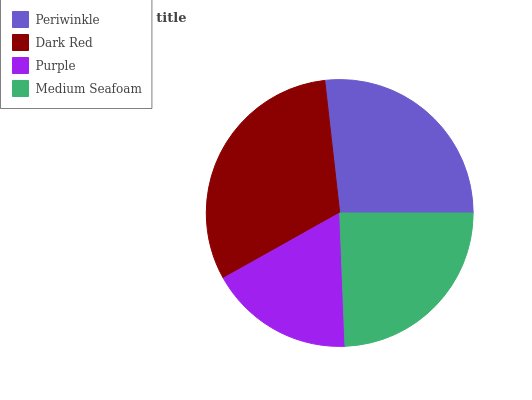Is Purple the minimum?
Answer yes or no. Yes. Is Dark Red the maximum?
Answer yes or no. Yes. Is Dark Red the minimum?
Answer yes or no. No. Is Purple the maximum?
Answer yes or no. No. Is Dark Red greater than Purple?
Answer yes or no. Yes. Is Purple less than Dark Red?
Answer yes or no. Yes. Is Purple greater than Dark Red?
Answer yes or no. No. Is Dark Red less than Purple?
Answer yes or no. No. Is Periwinkle the high median?
Answer yes or no. Yes. Is Medium Seafoam the low median?
Answer yes or no. Yes. Is Medium Seafoam the high median?
Answer yes or no. No. Is Purple the low median?
Answer yes or no. No. 